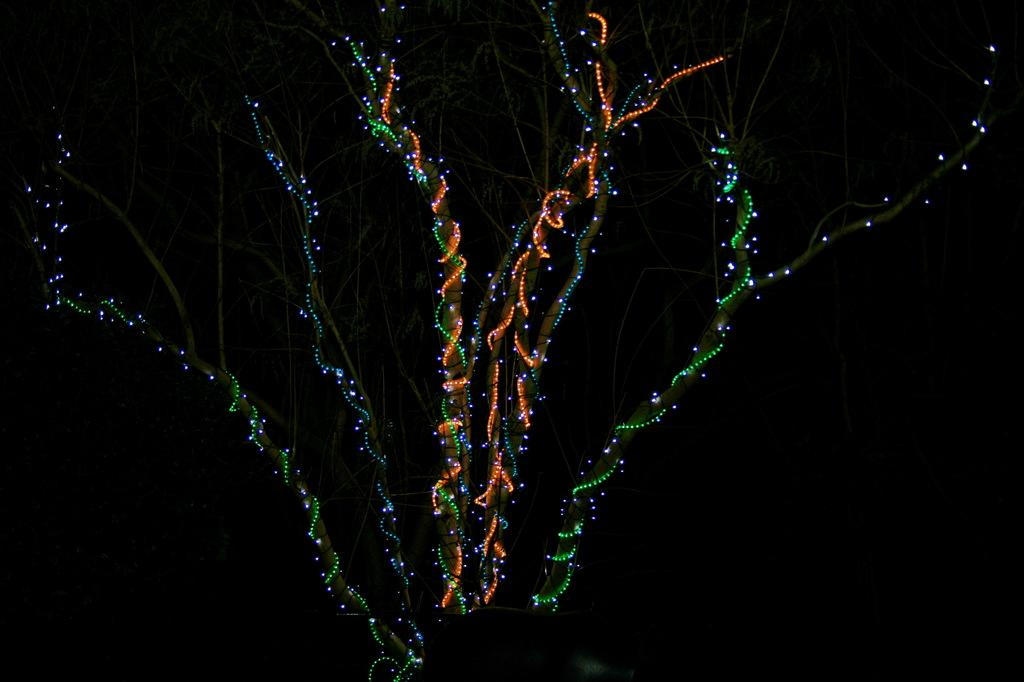What is illuminated in the image? There are lights on a tree in the image. What type of lights are used for illumination? The specific type of lights is not mentioned, but they are used to light up the tree. What is the purpose of the lights on the tree? The purpose of the lights on the tree is likely for decoration or to create a festive atmosphere. What patch of fabric is being compared to the table in the image? There is no patch of fabric or table present in the image; it only features lights on a tree. 